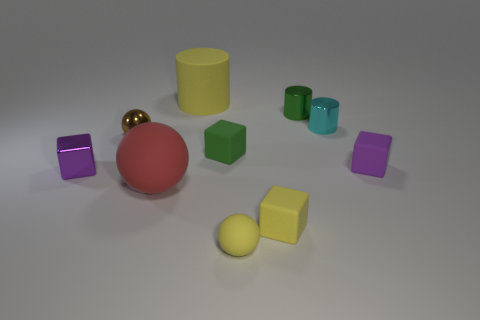Are there any other tiny blocks that have the same color as the shiny cube?
Ensure brevity in your answer.  Yes. What is the size of the matte block that is the same color as the small rubber sphere?
Offer a very short reply. Small. How many other things are made of the same material as the small cyan thing?
Your answer should be compact. 3. Do the yellow object in front of the small yellow rubber cube and the block to the left of the large rubber cylinder have the same material?
Make the answer very short. No. Are there any other things that have the same shape as the brown metal object?
Your answer should be compact. Yes. Do the yellow block and the tiny purple thing that is left of the large red rubber thing have the same material?
Offer a terse response. No. What color is the sphere in front of the tiny matte block in front of the big thing that is in front of the large yellow matte cylinder?
Ensure brevity in your answer.  Yellow. There is a purple metallic thing that is the same size as the cyan metallic object; what is its shape?
Make the answer very short. Cube. Is there anything else that has the same size as the metallic sphere?
Ensure brevity in your answer.  Yes. Is the size of the purple object left of the yellow matte cylinder the same as the rubber cube in front of the tiny metal block?
Your response must be concise. Yes. 